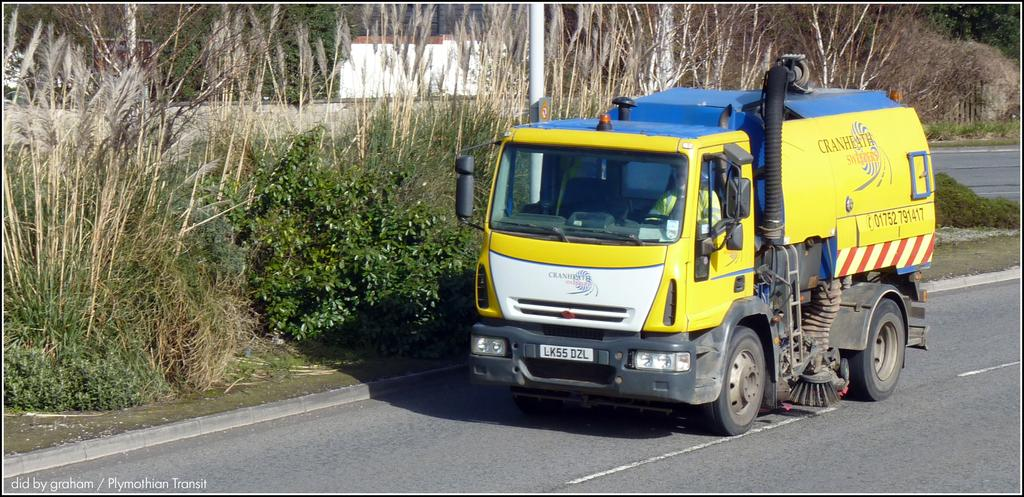What type of vehicle is in the image? There is a yellow color truck in the image. Where is the truck located? The truck is on the road. What other elements can be seen in the image besides the truck? There are green color plants and trees in the image. What type of insurance is the truck carrying in the image? There is no information about insurance in the image; it only shows a yellow color truck on the road with green color plants and trees in the background. 